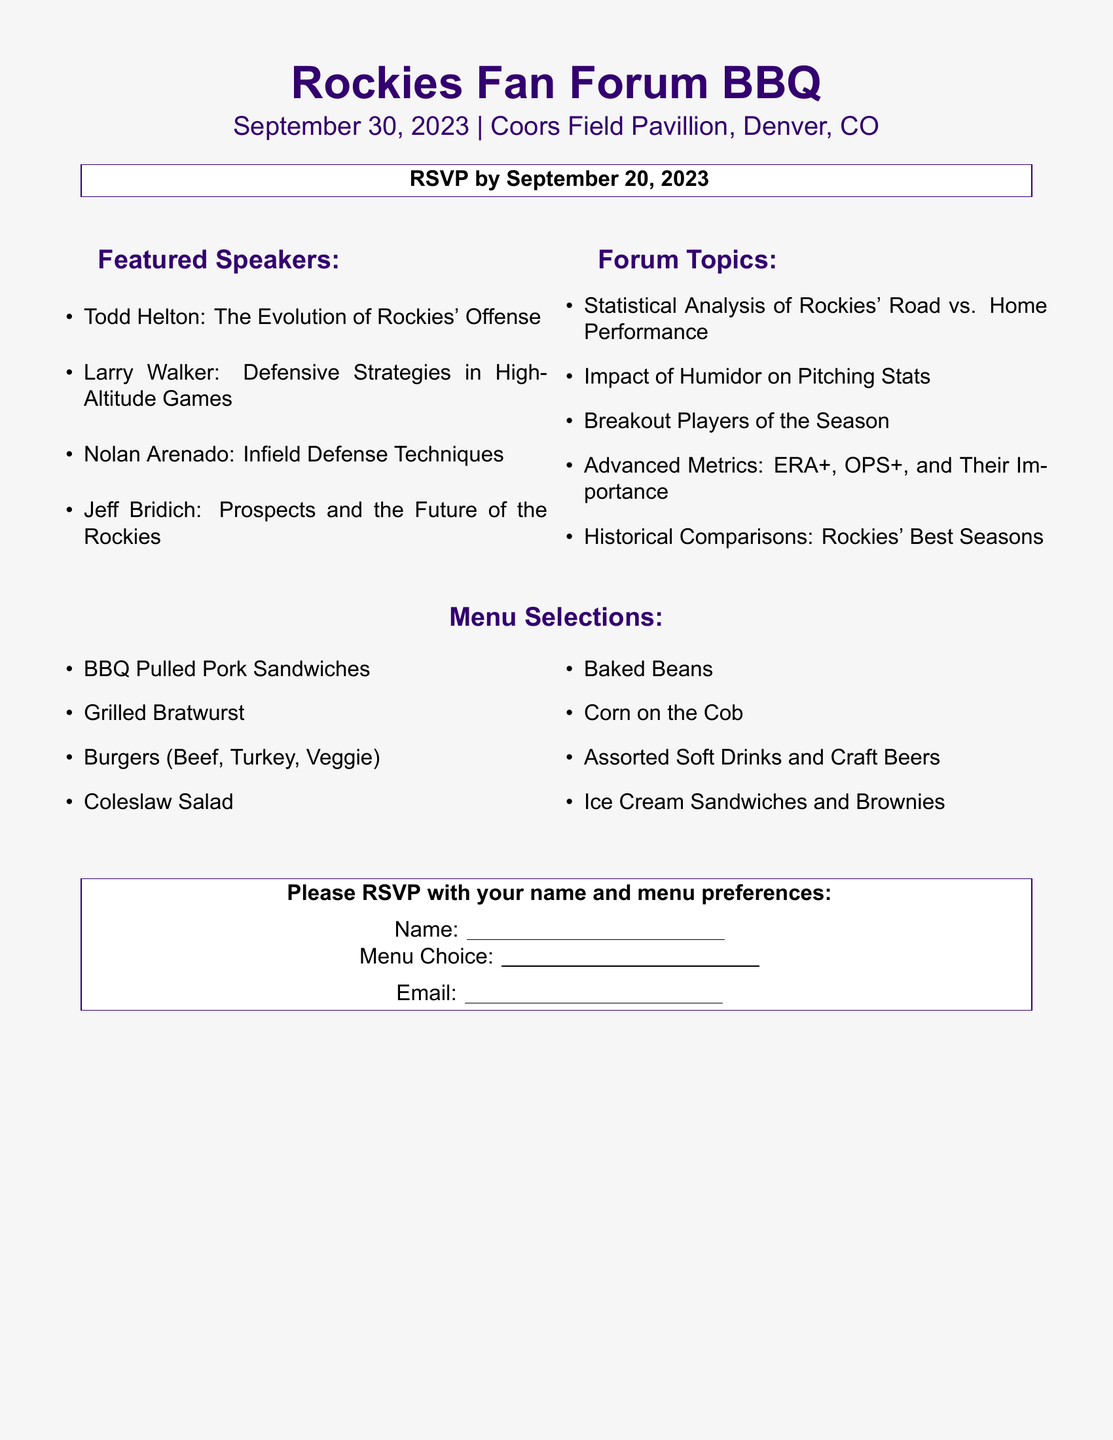what is the date of the Rockies Fan Forum BBQ? The date is specified in the document as September 30, 2023.
Answer: September 30, 2023 who is one of the featured speakers? The document lists Todd Helton, Larry Walker, Nolan Arenado, and Jeff Bridich among the featured speakers.
Answer: Todd Helton what is a topic of discussion in the forum? The topics include Statistical Analysis of Rockies' Road vs. Home Performance, Impact of Humidor on Pitching Stats, and others.
Answer: Statistical Analysis of Rockies' Road vs. Home Performance how many menu selections are listed? There are a total of 8 menu selections mentioned in the document.
Answer: 8 what is the RSVP deadline for the event? The RSVP deadline is provided as September 20, 2023.
Answer: September 20, 2023 which beverage options are available at the BBQ? The menu specifies Assorted Soft Drinks and Craft Beers as beverage options.
Answer: Assorted Soft Drinks and Craft Beers who will discuss "Infield Defense Techniques"? The document states that Nolan Arenado will discuss Infield Defense Techniques.
Answer: Nolan Arenado what type of food is the first item on the menu? BBQ Pulled Pork Sandwiches is the first menu item listed.
Answer: BBQ Pulled Pork Sandwiches what should attendees include when they RSVP? Attendees should include their name and menu preferences in their RSVP.
Answer: Name and menu preferences 